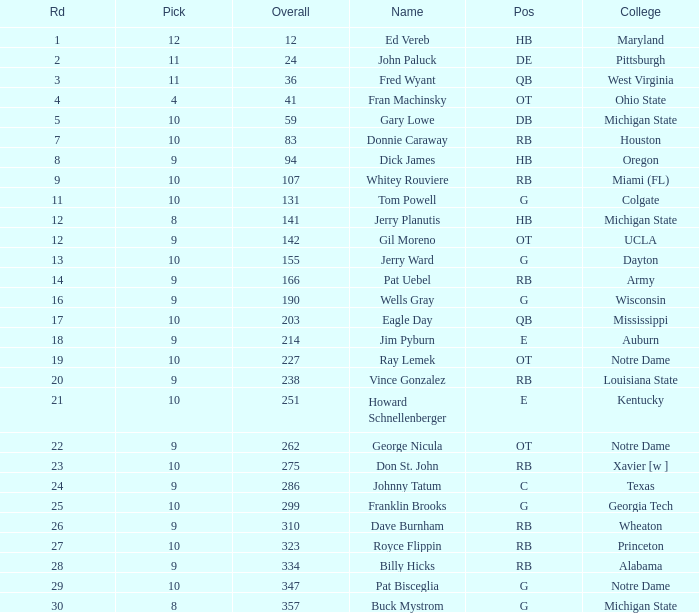What is the highest round number for donnie caraway? 7.0. 